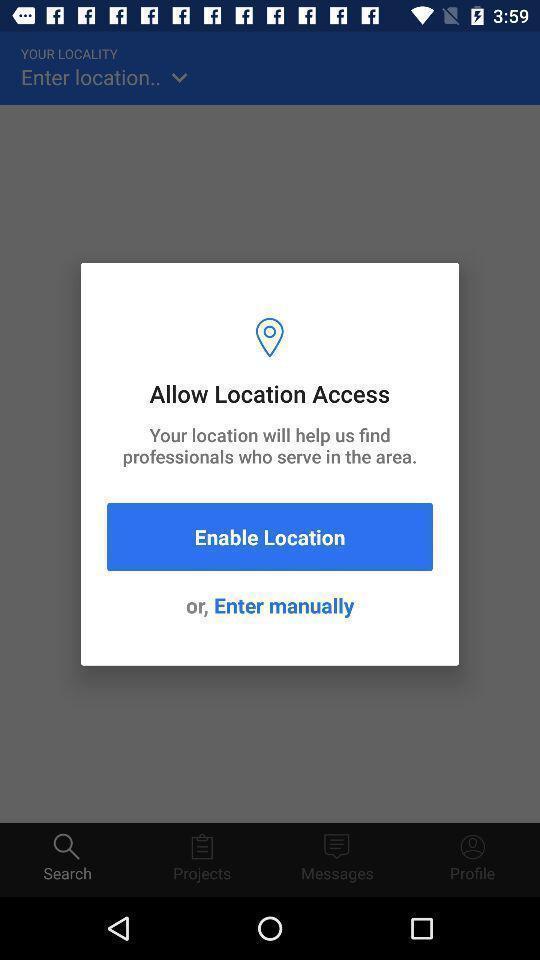Explain the elements present in this screenshot. Pop up showing details about location. 